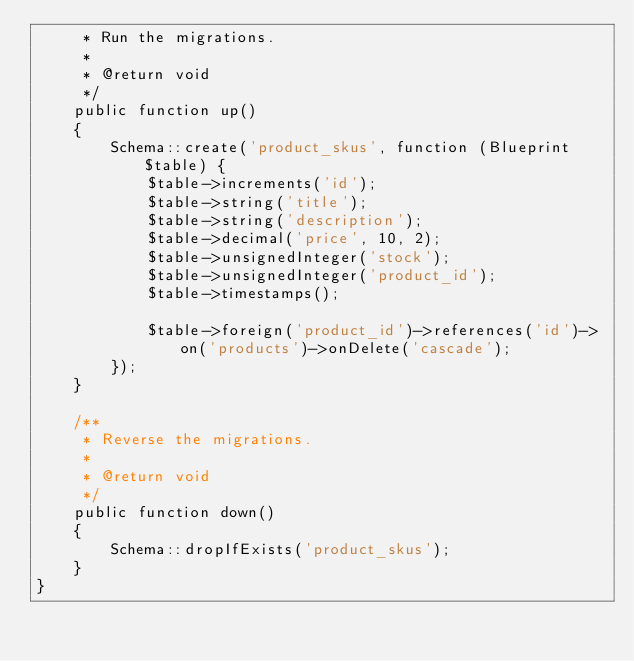<code> <loc_0><loc_0><loc_500><loc_500><_PHP_>     * Run the migrations.
     *
     * @return void
     */
    public function up()
    {
        Schema::create('product_skus', function (Blueprint $table) {
            $table->increments('id');
            $table->string('title');
            $table->string('description');
            $table->decimal('price', 10, 2);
            $table->unsignedInteger('stock');
            $table->unsignedInteger('product_id');
            $table->timestamps();

            $table->foreign('product_id')->references('id')->on('products')->onDelete('cascade');
        });
    }

    /**
     * Reverse the migrations.
     *
     * @return void
     */
    public function down()
    {
        Schema::dropIfExists('product_skus');
    }
}
</code> 